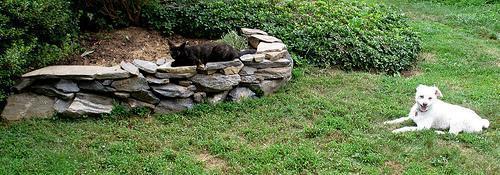How many cats are there?
Give a very brief answer. 1. How many animals are laying on the grass?
Give a very brief answer. 1. 